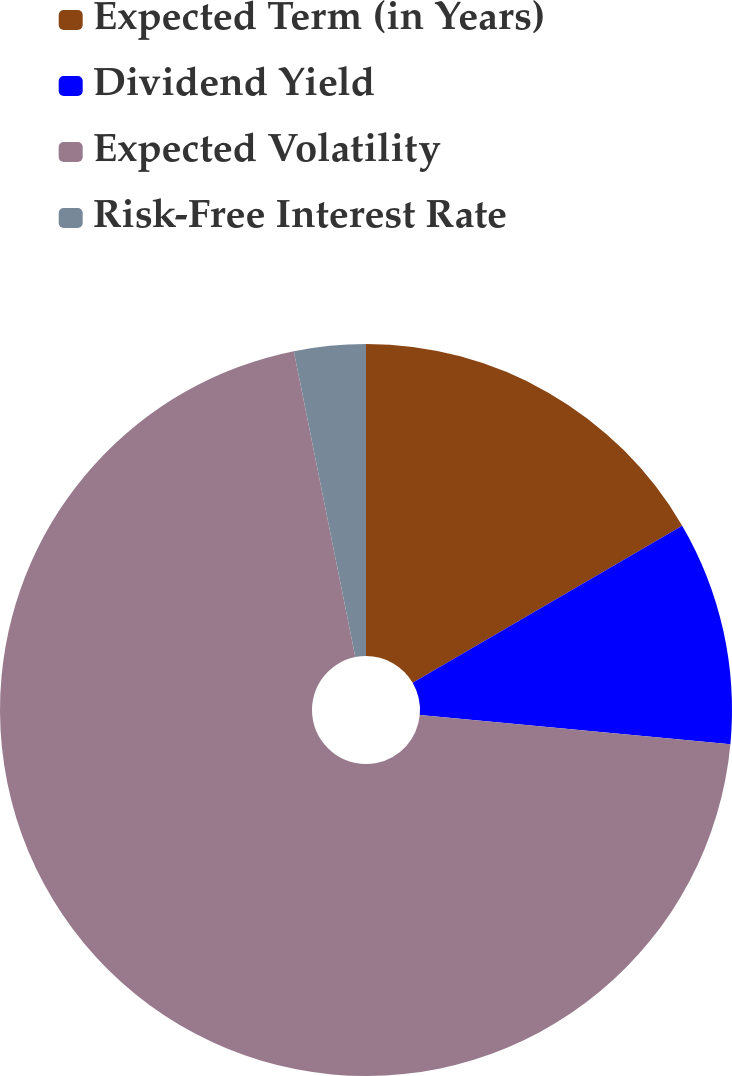Convert chart. <chart><loc_0><loc_0><loc_500><loc_500><pie_chart><fcel>Expected Term (in Years)<fcel>Dividend Yield<fcel>Expected Volatility<fcel>Risk-Free Interest Rate<nl><fcel>16.6%<fcel>9.89%<fcel>70.36%<fcel>3.16%<nl></chart> 